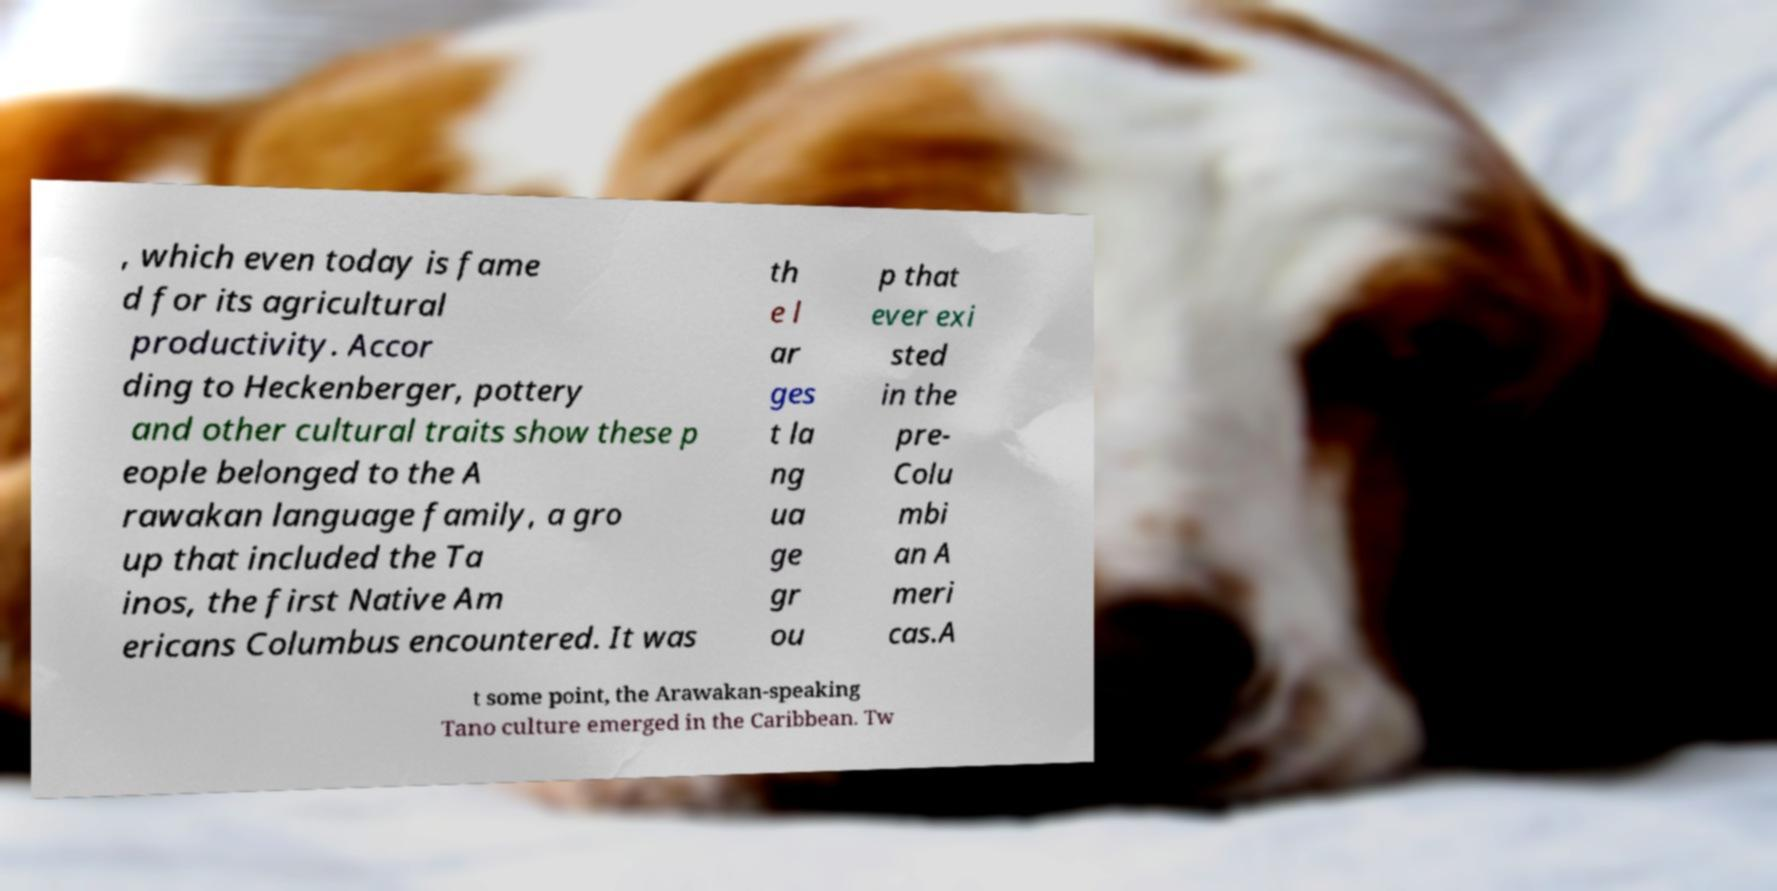What messages or text are displayed in this image? I need them in a readable, typed format. , which even today is fame d for its agricultural productivity. Accor ding to Heckenberger, pottery and other cultural traits show these p eople belonged to the A rawakan language family, a gro up that included the Ta inos, the first Native Am ericans Columbus encountered. It was th e l ar ges t la ng ua ge gr ou p that ever exi sted in the pre- Colu mbi an A meri cas.A t some point, the Arawakan-speaking Tano culture emerged in the Caribbean. Tw 